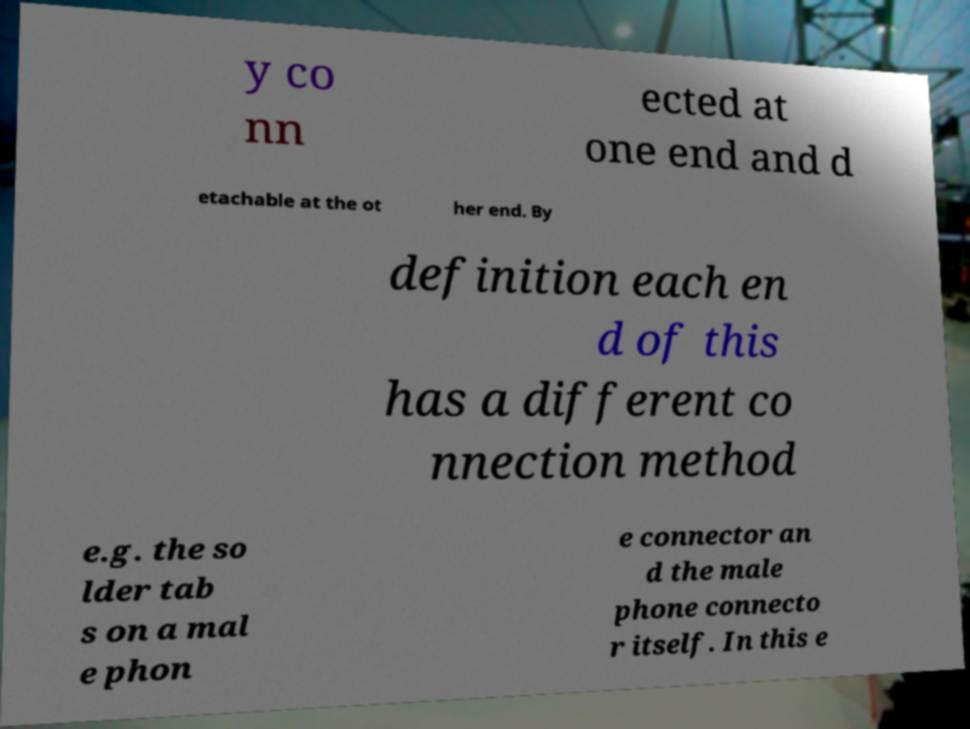There's text embedded in this image that I need extracted. Can you transcribe it verbatim? y co nn ected at one end and d etachable at the ot her end. By definition each en d of this has a different co nnection method e.g. the so lder tab s on a mal e phon e connector an d the male phone connecto r itself. In this e 